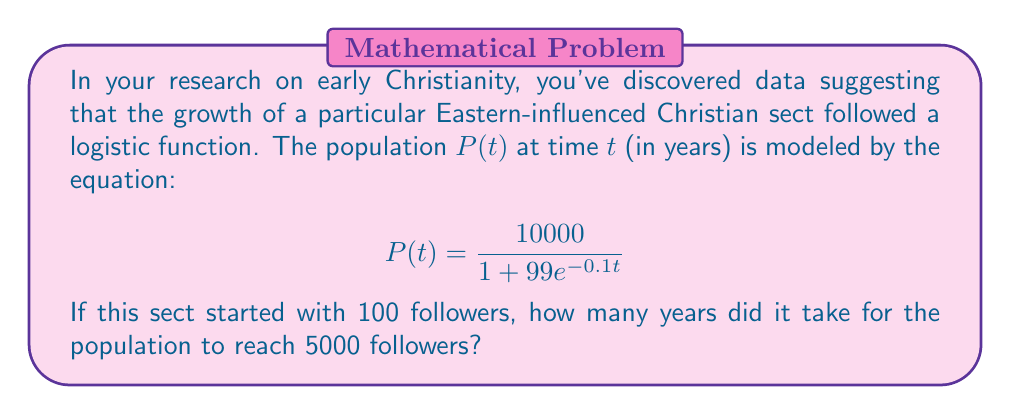Can you solve this math problem? To solve this problem, we'll follow these steps:

1) The logistic function is given by:
   $$P(t) = \frac{10000}{1 + 99e^{-0.1t}}$$

2) We need to find $t$ when $P(t) = 5000$. Let's set up the equation:
   $$5000 = \frac{10000}{1 + 99e^{-0.1t}}$$

3) Multiply both sides by $(1 + 99e^{-0.1t})$:
   $$5000(1 + 99e^{-0.1t}) = 10000$$

4) Distribute on the left side:
   $$5000 + 495000e^{-0.1t} = 10000$$

5) Subtract 5000 from both sides:
   $$495000e^{-0.1t} = 5000$$

6) Divide both sides by 495000:
   $$e^{-0.1t} = \frac{1}{99}$$

7) Take the natural log of both sides:
   $$-0.1t = \ln(\frac{1}{99})$$

8) Divide both sides by -0.1:
   $$t = -10\ln(\frac{1}{99}) = 10\ln(99)$$

9) Calculate the result:
   $$t \approx 46.05$$

Therefore, it took approximately 46.05 years for the sect to reach 5000 followers.
Answer: 46.05 years 